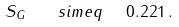<formula> <loc_0><loc_0><loc_500><loc_500>S _ { G } \quad s i m e q \ \ 0 . 2 2 1 \, .</formula> 